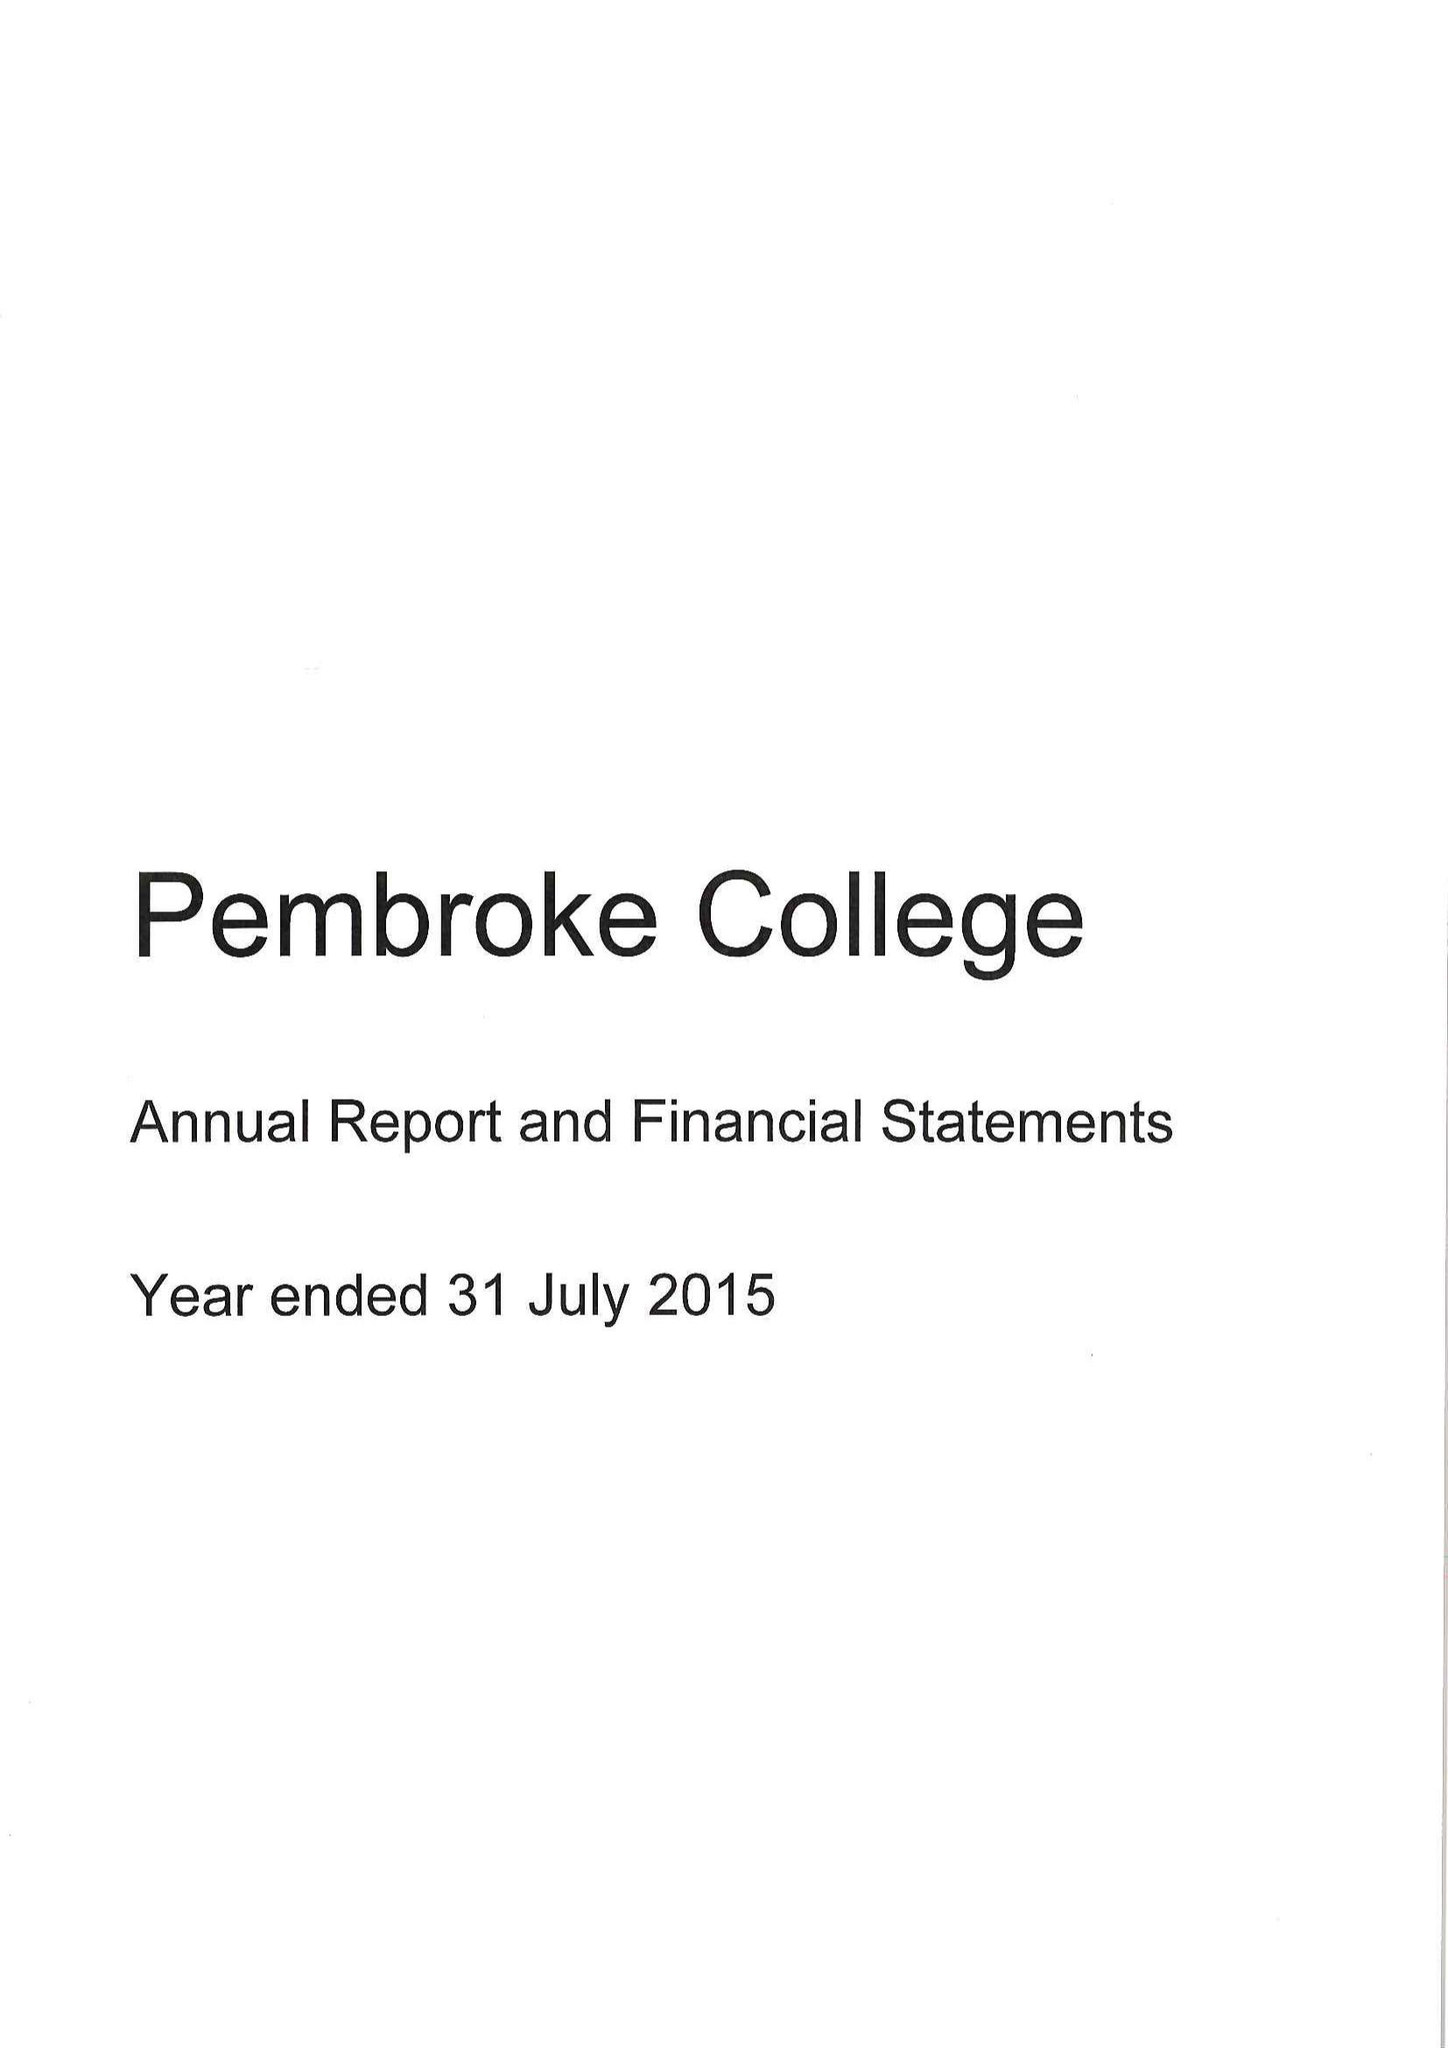What is the value for the income_annually_in_british_pounds?
Answer the question using a single word or phrase. 11101000.00 